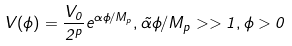Convert formula to latex. <formula><loc_0><loc_0><loc_500><loc_500>V ( \phi ) = { \frac { V _ { 0 } } { 2 ^ { p } } } e ^ { { \alpha } \phi / M _ { p } } , \tilde { \alpha } \phi / M _ { p } > > 1 , \phi > 0</formula> 